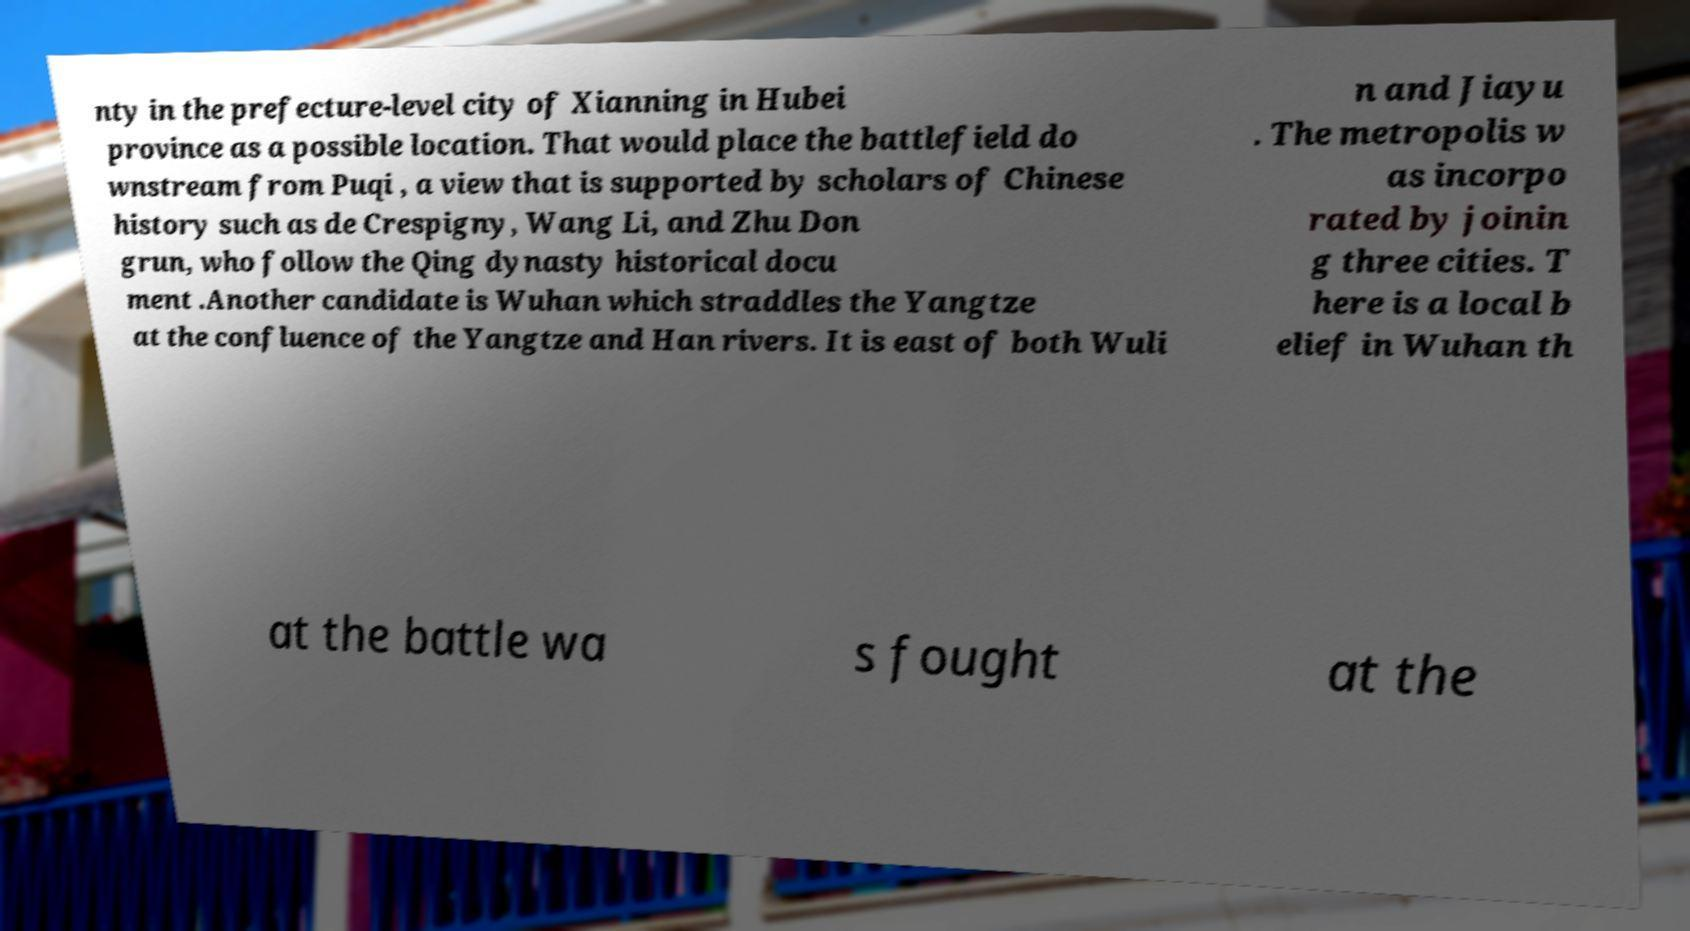Could you extract and type out the text from this image? nty in the prefecture-level city of Xianning in Hubei province as a possible location. That would place the battlefield do wnstream from Puqi , a view that is supported by scholars of Chinese history such as de Crespigny, Wang Li, and Zhu Don grun, who follow the Qing dynasty historical docu ment .Another candidate is Wuhan which straddles the Yangtze at the confluence of the Yangtze and Han rivers. It is east of both Wuli n and Jiayu . The metropolis w as incorpo rated by joinin g three cities. T here is a local b elief in Wuhan th at the battle wa s fought at the 